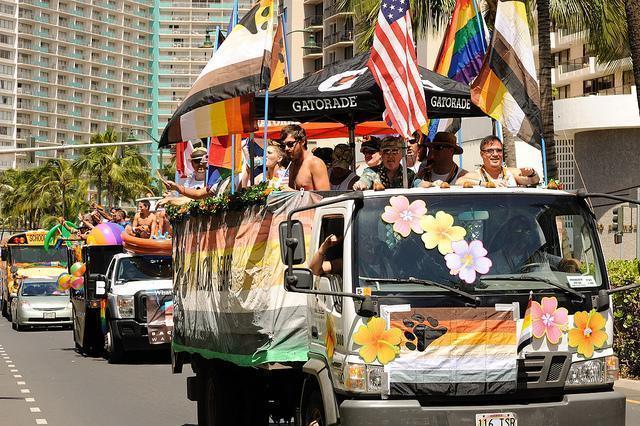Which company manufactures this beverage?
Indicate the correct response by choosing from the four available options to answer the question.
Options: Nestle, heineken, coca cola, pepsico. Pepsico. 